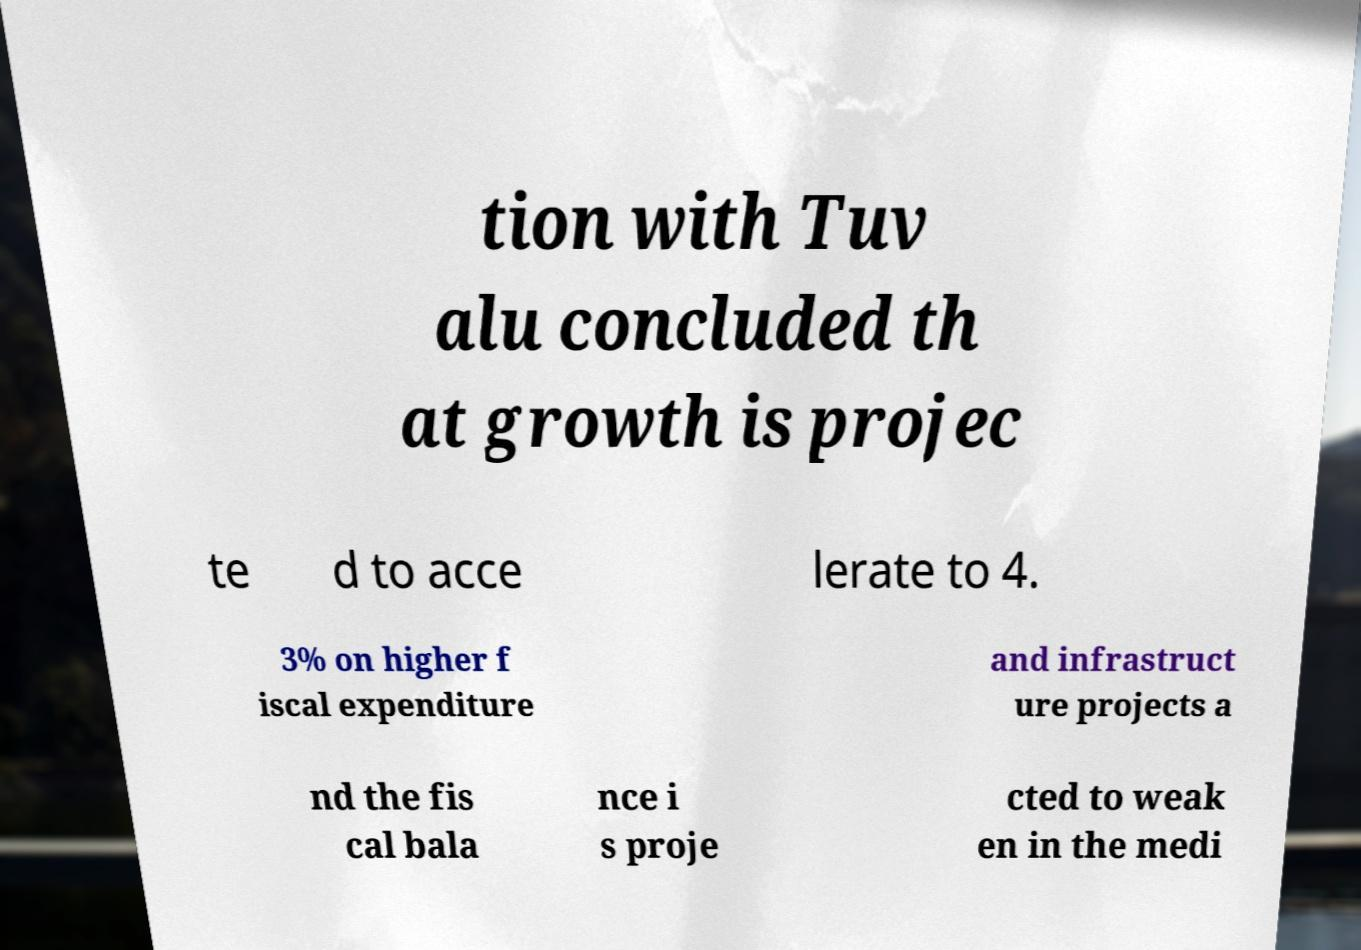Could you extract and type out the text from this image? tion with Tuv alu concluded th at growth is projec te d to acce lerate to 4. 3% on higher f iscal expenditure and infrastruct ure projects a nd the fis cal bala nce i s proje cted to weak en in the medi 